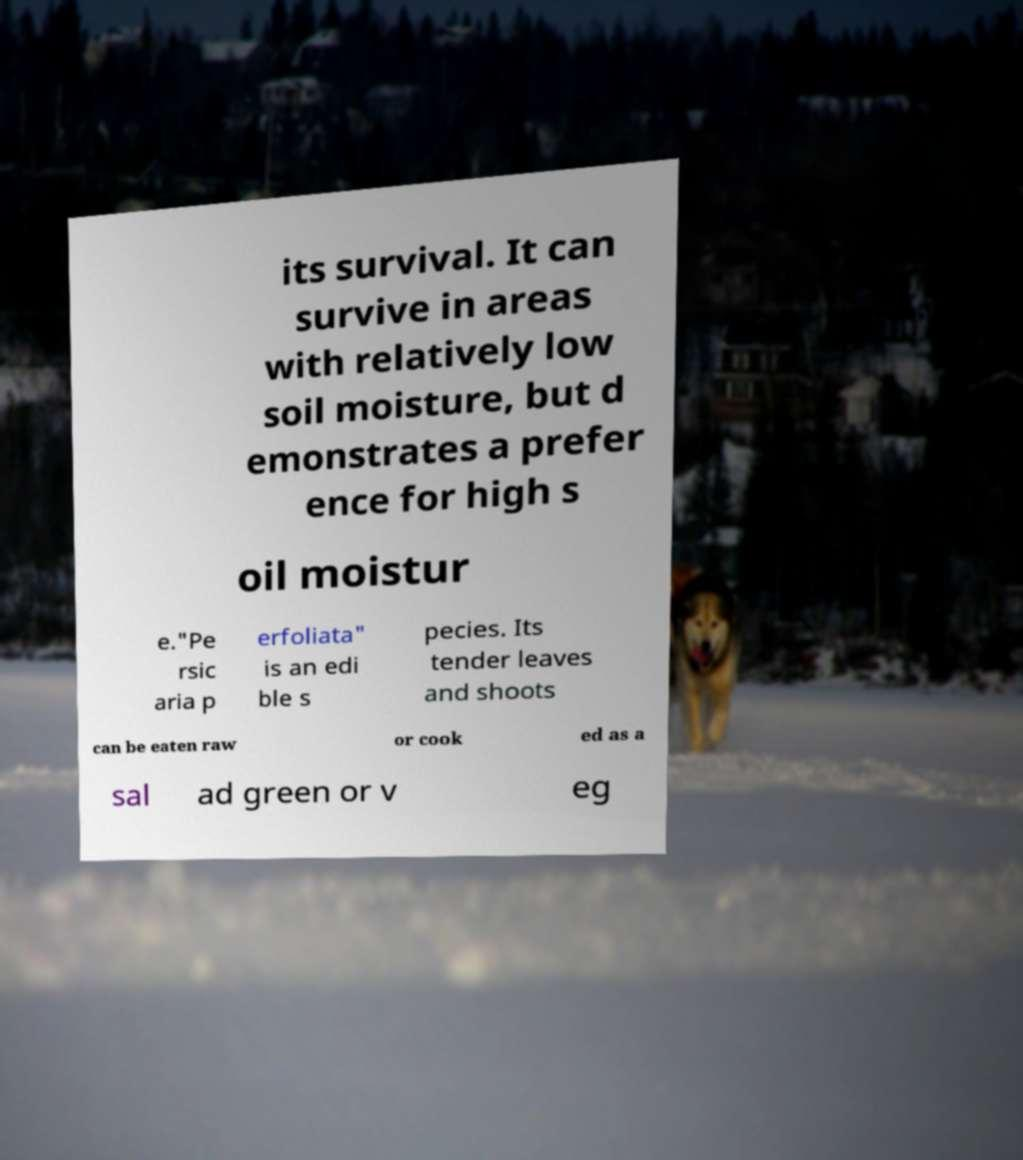Could you assist in decoding the text presented in this image and type it out clearly? its survival. It can survive in areas with relatively low soil moisture, but d emonstrates a prefer ence for high s oil moistur e."Pe rsic aria p erfoliata" is an edi ble s pecies. Its tender leaves and shoots can be eaten raw or cook ed as a sal ad green or v eg 